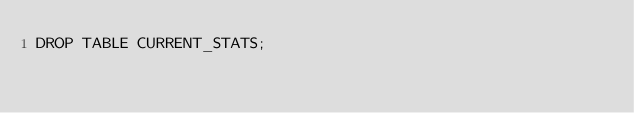<code> <loc_0><loc_0><loc_500><loc_500><_SQL_>DROP TABLE CURRENT_STATS;
</code> 